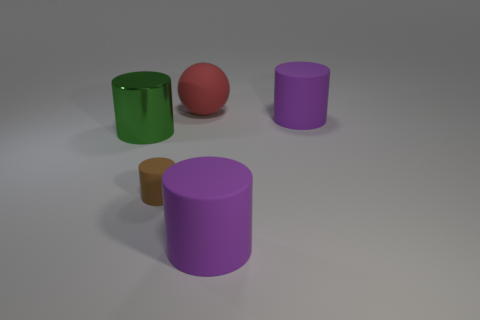Is the green shiny cylinder the same size as the brown object?
Your response must be concise. No. How many other things are there of the same material as the brown cylinder?
Keep it short and to the point. 3. Are there any purple matte cylinders that are in front of the big matte cylinder behind the large green metallic cylinder?
Provide a succinct answer. Yes. There is a thing that is both behind the small matte cylinder and left of the rubber ball; what is it made of?
Offer a very short reply. Metal. The brown object that is made of the same material as the large red object is what shape?
Offer a very short reply. Cylinder. Is there anything else that is the same shape as the red rubber thing?
Ensure brevity in your answer.  No. Are the large purple object in front of the small thing and the red sphere made of the same material?
Your response must be concise. Yes. There is a large purple cylinder that is in front of the brown matte object; what is it made of?
Offer a very short reply. Rubber. There is a purple thing that is behind the tiny brown object in front of the large metal object; what is its size?
Keep it short and to the point. Large. What number of purple things have the same size as the red matte ball?
Your response must be concise. 2. 